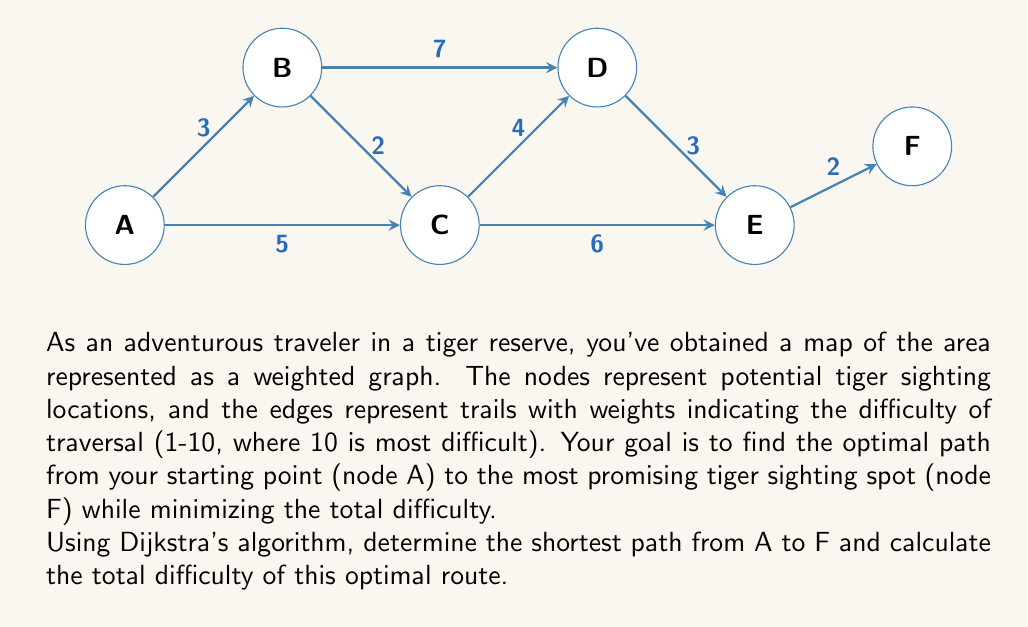Could you help me with this problem? To solve this problem using Dijkstra's algorithm, we'll follow these steps:

1) Initialize:
   - Set distance to A as 0, and all other nodes as infinity.
   - Set all nodes as unvisited.
   - Set A as the current node.

2) For the current node, consider all unvisited neighbors and calculate their tentative distances.
   - If the calculated distance is less than the previously recorded distance, update it.

3) Mark the current node as visited and remove it from the unvisited set.

4) If the destination node (F) has been marked visited, we're done.
   Otherwise, select the unvisited node with the smallest tentative distance and set it as the new current node. Go back to step 2.

Let's apply the algorithm:

Starting at A:
- Update B: min(∞, 0+3) = 3
- Update C: min(∞, 0+5) = 5

Mark A as visited. Current shortest paths:
A→B (3), A→C (5)

At B (smallest unvisited):
- Update D: min(∞, 3+7) = 10
- Update C: min(5, 3+2) = 5 (no change)

Mark B as visited. Current shortest paths:
A→B (3), A→C (5), A→B→D (10)

At C:
- Update D: min(10, 5+4) = 9
- Update E: min(∞, 5+6) = 11

Mark C as visited. Current shortest paths:
A→B (3), A→C (5), A→C→D (9), A→C→E (11)

At D:
- Update E: min(11, 9+3) = 11 (no change)
- Update F: min(∞, 9+2) = 11

Mark D as visited. Current shortest paths:
A→B (3), A→C (5), A→C→D (9), A→C→E (11), A→C→D→F (11)

At E:
- Update F: min(11, 11+2) = 11 (no change)

Mark E as visited.

F is now the only unvisited node, so we're done.

The shortest path is A→C→D→F with a total difficulty of 11.
Answer: A→C→D→F, 11 